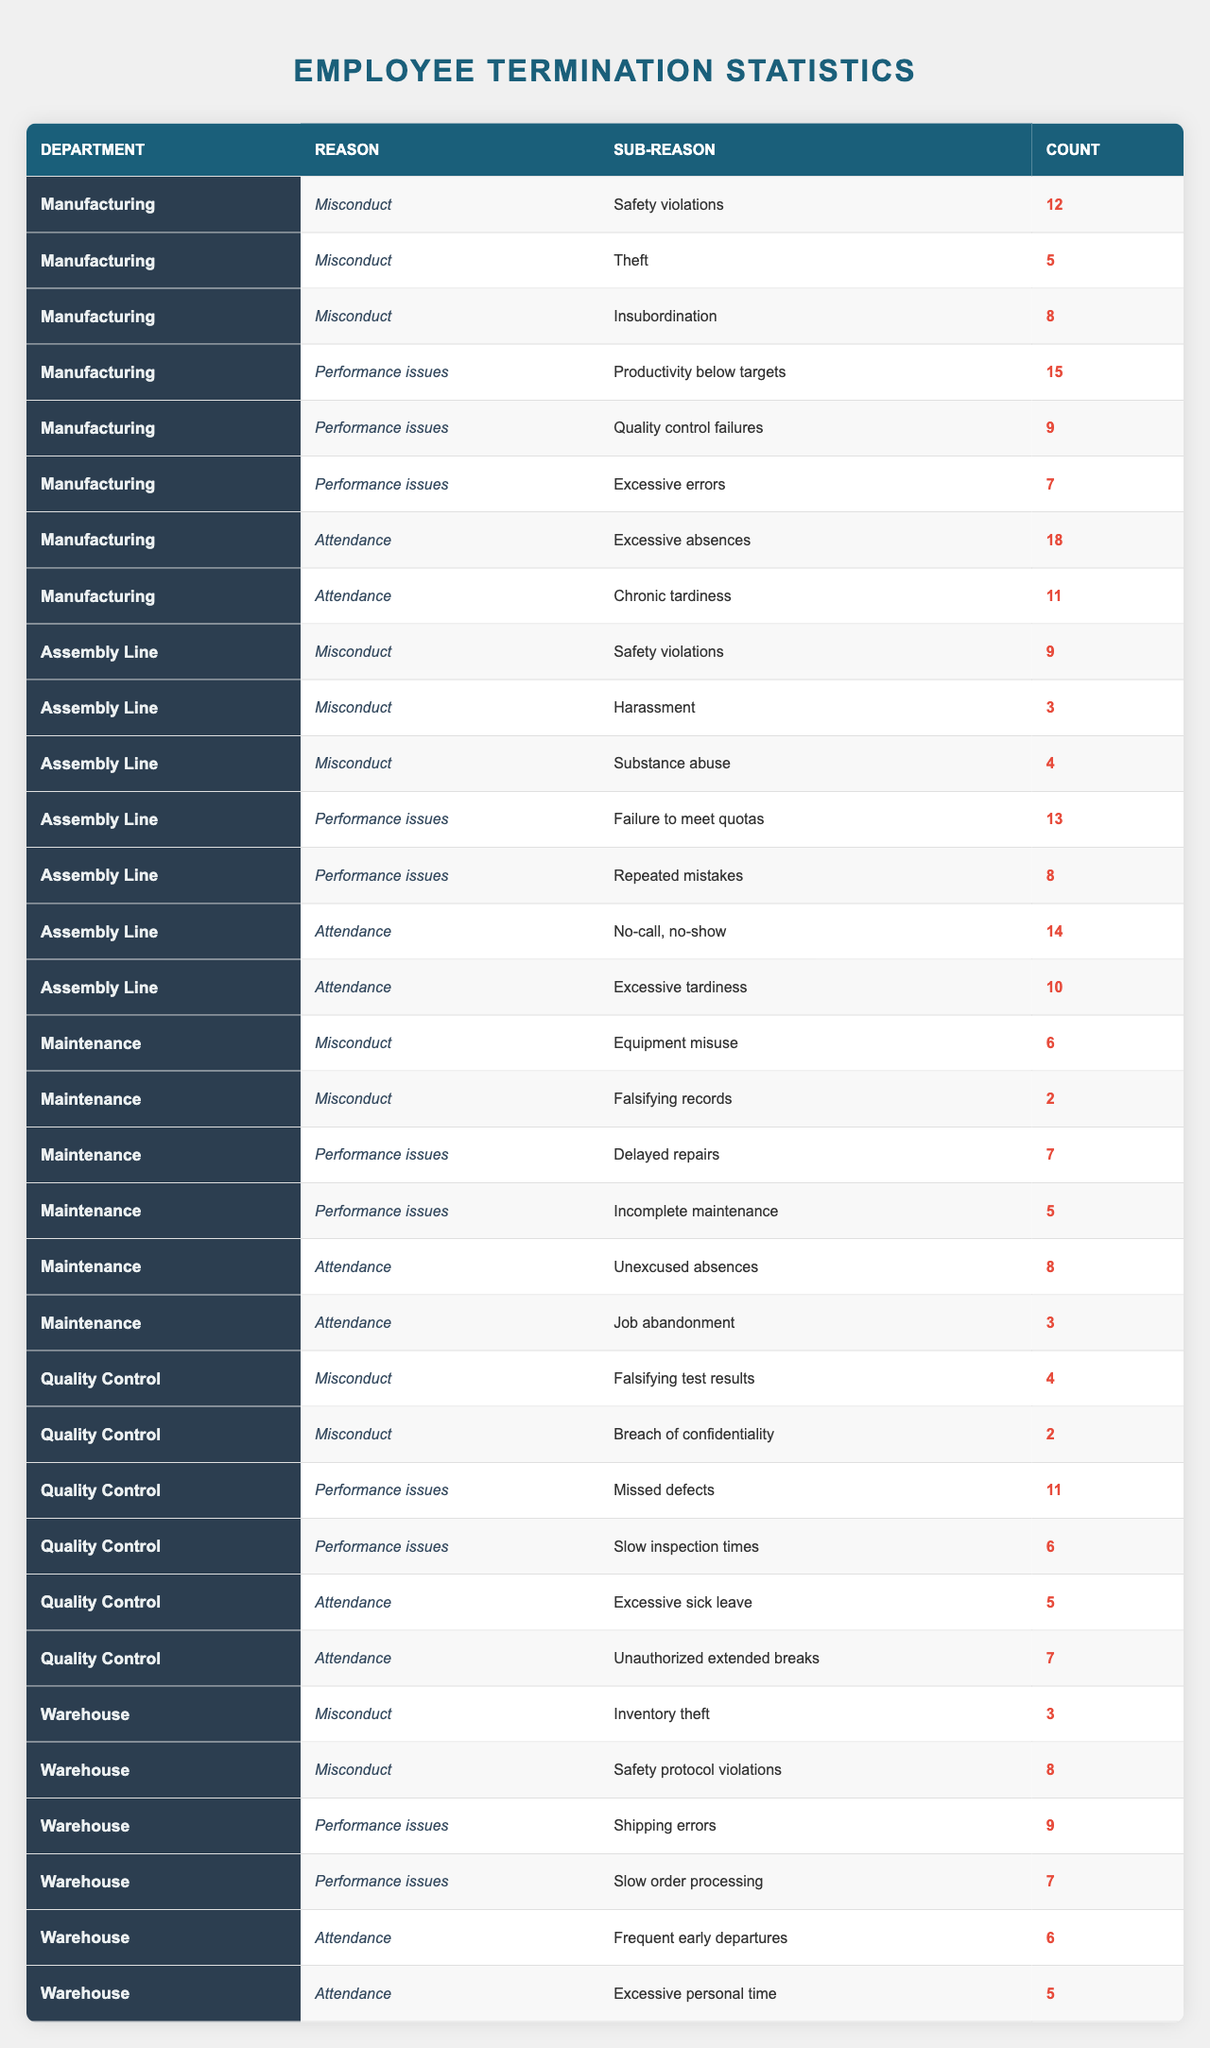What is the total number of terminations in the Manufacturing department due to misconduct? In the Manufacturing department, the misconduct reasons are Safety violations (12), Theft (5), and Insubordination (8). Adding these counts gives: 12 + 5 + 8 = 25.
Answer: 25 Which department had the highest number of terminations for performance issues? In the Performance issues category, Manufacturing had 31 (15 + 9 + 7), Assembly Line had 21 (13 + 8), Maintenance had 12 (7 + 5), Quality Control had 17 (11 + 6), and Warehouse had 16 (9 + 7). The highest is Manufacturing with 31.
Answer: Manufacturing Is there any department with terminations solely due to misconduct without any performance or attendance issues? The Maintenance department has misconduct counts of Equipment misuse (6) and Falsifying records (2) but does not have a performance issue listed with totals equal to zero. Thus, no department fits this criteria of solely misconduct without other issues.
Answer: No What is the average number of terminations for attendance issues across all departments? The attendance counts are: Manufacturing (29), Assembly Line (24), Maintenance (11), Quality Control (12), and Warehouse (11). Adding them gives a total of 87, divided by 5 gives an average of 17.4.
Answer: 17.4 Which misconduct category has the lowest number of total terminations across all departments? The misconduct categories are: Safety violations (21), Theft (8), Insubordination (8), Harassment (3), Substance abuse (4), Equipment misuse (6), Falsifying records (2), Falsifying test results (4), and Breach of confidentiality (2), Inventory theft (3), and Safety protocol violations (8). Falsifying records and Breach of confidentiality both have 2, which is the lowest.
Answer: Falsifying records and Breach of confidentiality How many terminations in the Assembly Line department were due to attendance issues? The Assembly Line has two attendance reasons: No-call, no-show (14) and Excessive tardiness (10). Adding these counts gives: 14 + 10 = 24.
Answer: 24 Which department had the most instances of excessive absences leading to termination? The Manufacturing department lists Excessive absences with 18 terminations. The other departments had fewer instances in the Attendance category.
Answer: Manufacturing What is the total number of terminations across all departments due to performance issues? The total counts for performance issues are: Manufacturing (31), Assembly Line (21), Maintenance (12), Quality Control (17), and Warehouse (16). Adding these: 31 + 21 + 12 + 17 + 16 = 97.
Answer: 97 How many more instances of misconduct due to safety violations are there in the Manufacturing department compared to the Warehouse department? Manufacturing had 12 safety violations while Warehouse had 8. The difference is 12 - 8 = 4.
Answer: 4 Are there fewer terminations in the Maintenance department for misconduct than for attendance? The Maintenance department had 8 misconduct terminations and 11 attendance terminations. Since 11 > 8, there are indeed fewer misconduct terminations.
Answer: Yes What is the total count of terminations due to 'Unauthorized extended breaks' in the Quality Control department? The Quality Control department has 7 terminations for 'Unauthorized extended breaks' in the Attendance category. This count is explicitly listed in the provided data.
Answer: 7 